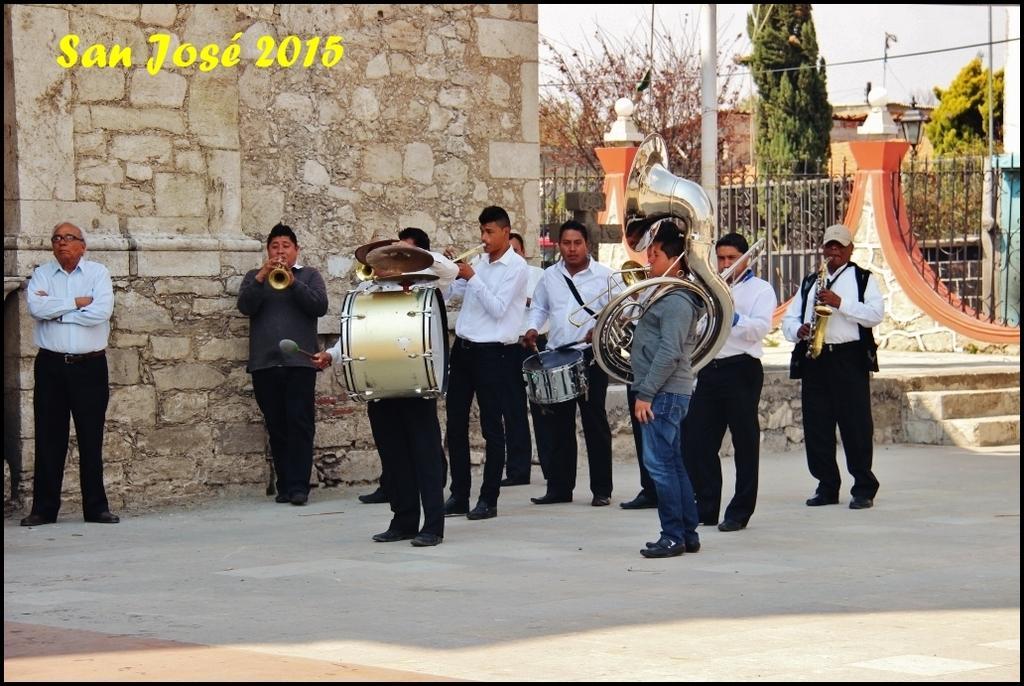Could you give a brief overview of what you see in this image? A musical band is playing musical instruments standing on a road. They are wearing white shirt and black pant as a uniform. They are standing beside a structure. There are some trees and a barrier wall in the background. 